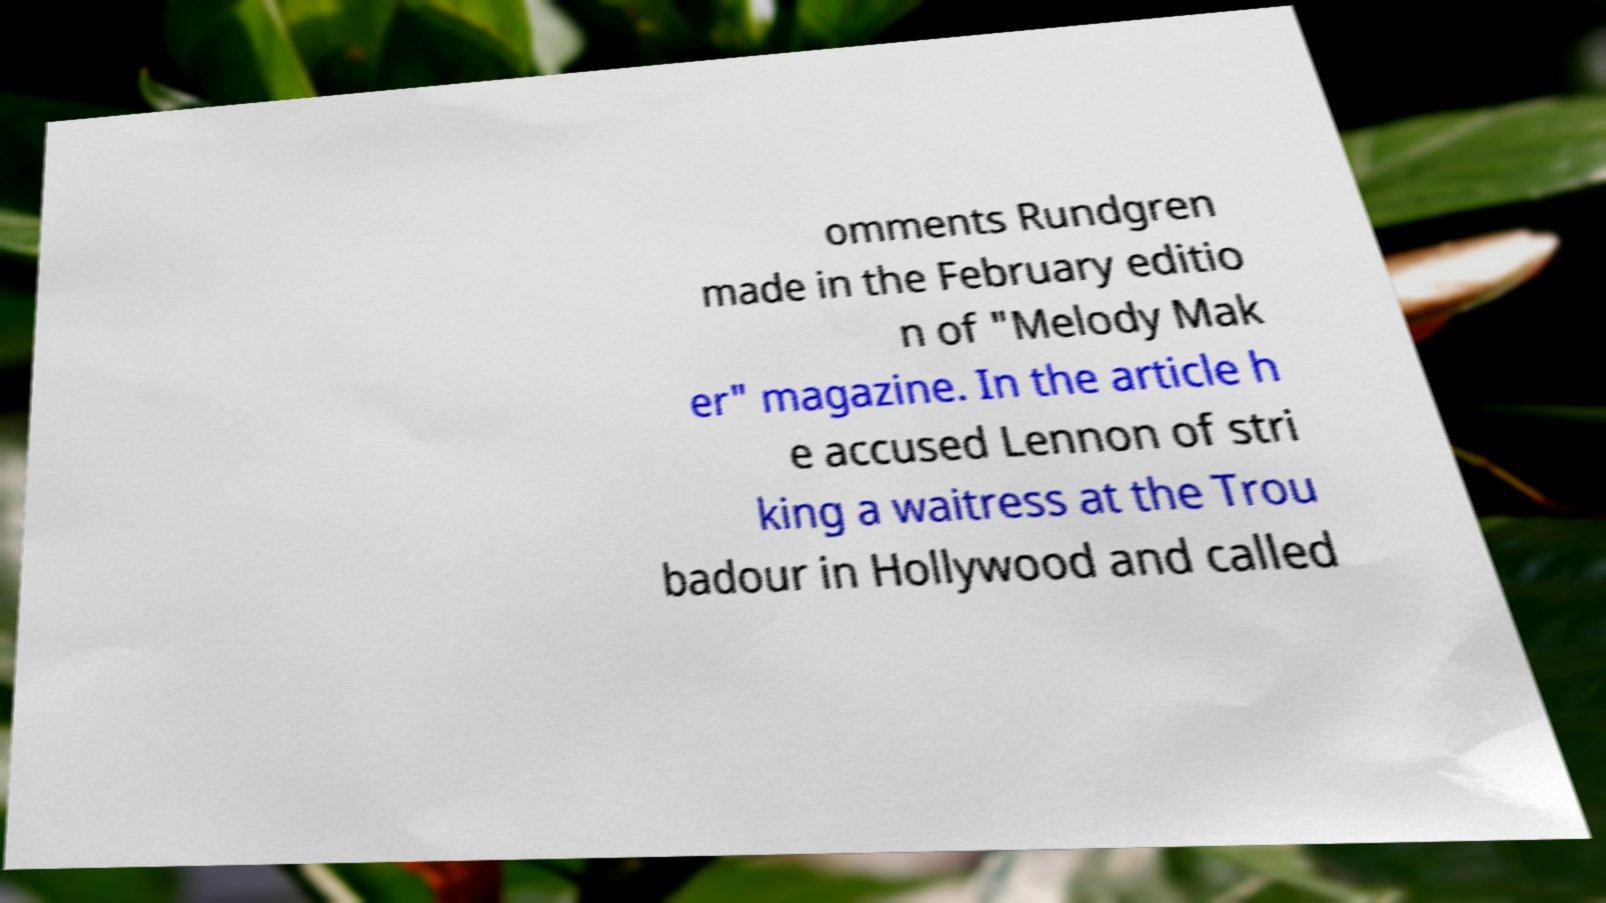Can you read and provide the text displayed in the image?This photo seems to have some interesting text. Can you extract and type it out for me? omments Rundgren made in the February editio n of "Melody Mak er" magazine. In the article h e accused Lennon of stri king a waitress at the Trou badour in Hollywood and called 